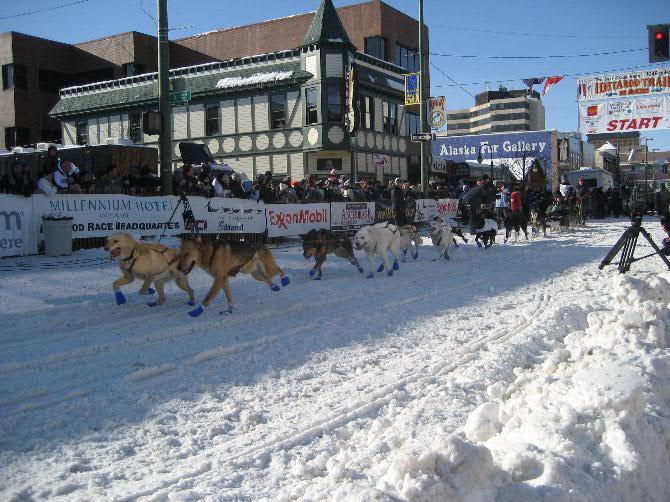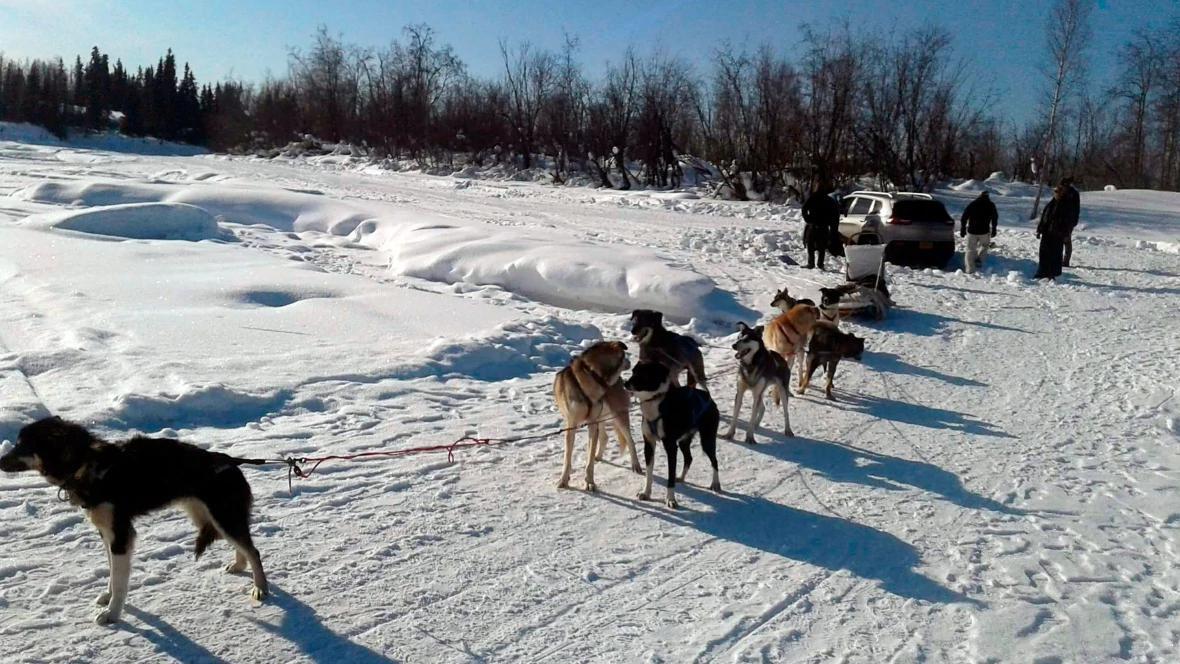The first image is the image on the left, the second image is the image on the right. Given the left and right images, does the statement "There are exactly two people in the image on the left." hold true? Answer yes or no. No. 